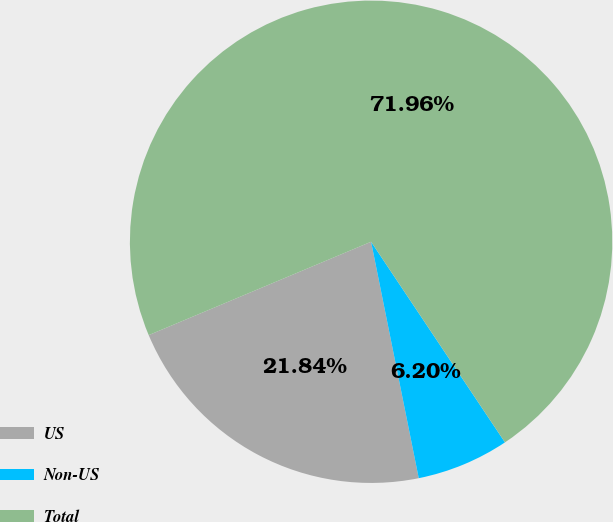<chart> <loc_0><loc_0><loc_500><loc_500><pie_chart><fcel>US<fcel>Non-US<fcel>Total<nl><fcel>21.84%<fcel>6.2%<fcel>71.96%<nl></chart> 